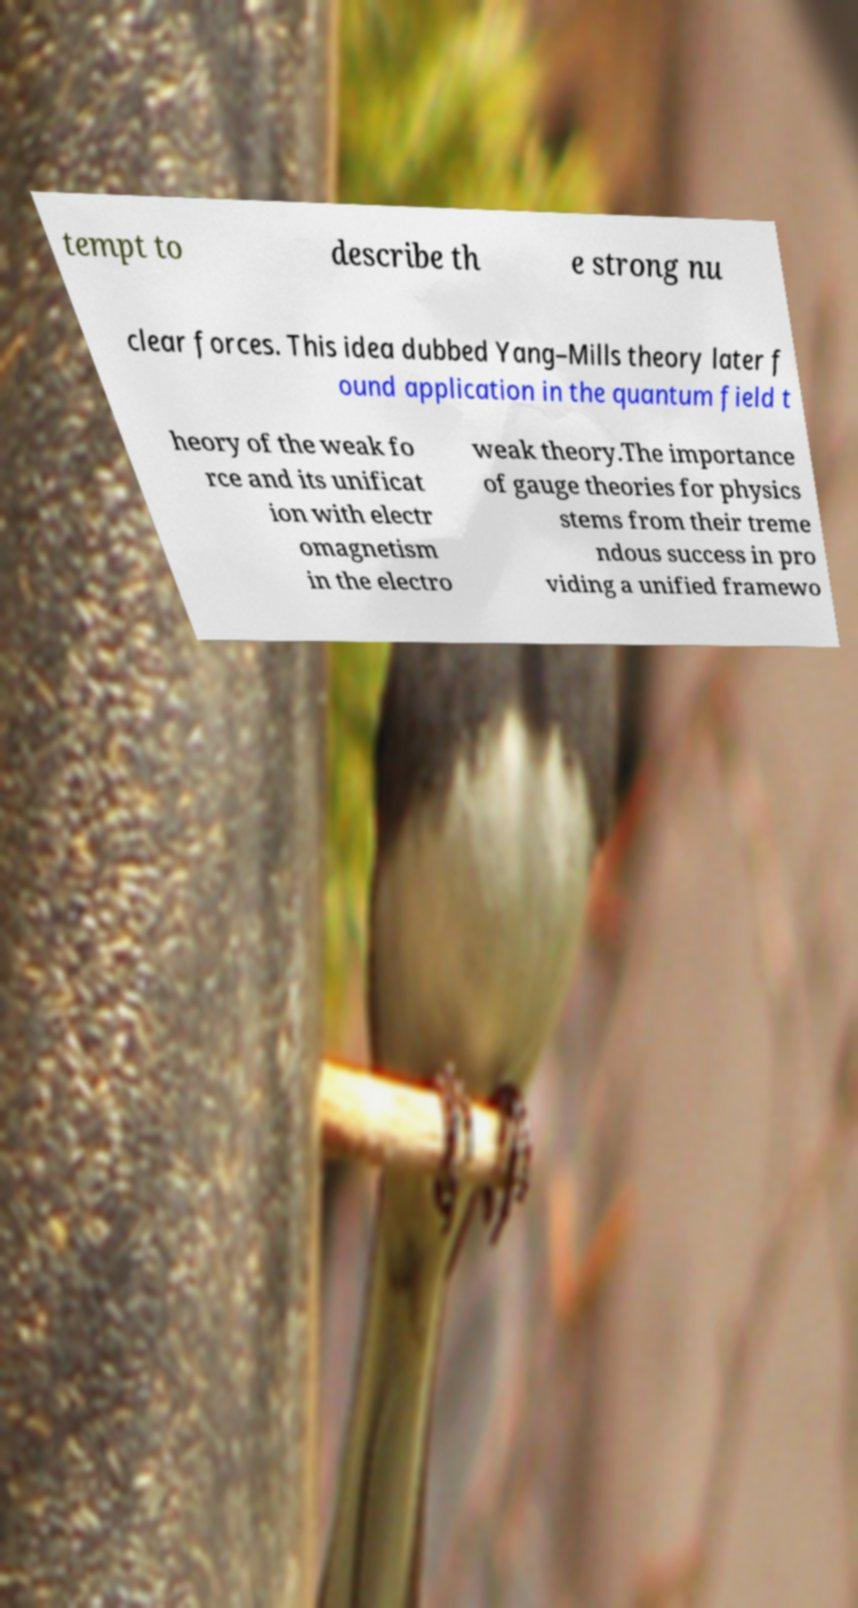Can you accurately transcribe the text from the provided image for me? tempt to describe th e strong nu clear forces. This idea dubbed Yang–Mills theory later f ound application in the quantum field t heory of the weak fo rce and its unificat ion with electr omagnetism in the electro weak theory.The importance of gauge theories for physics stems from their treme ndous success in pro viding a unified framewo 